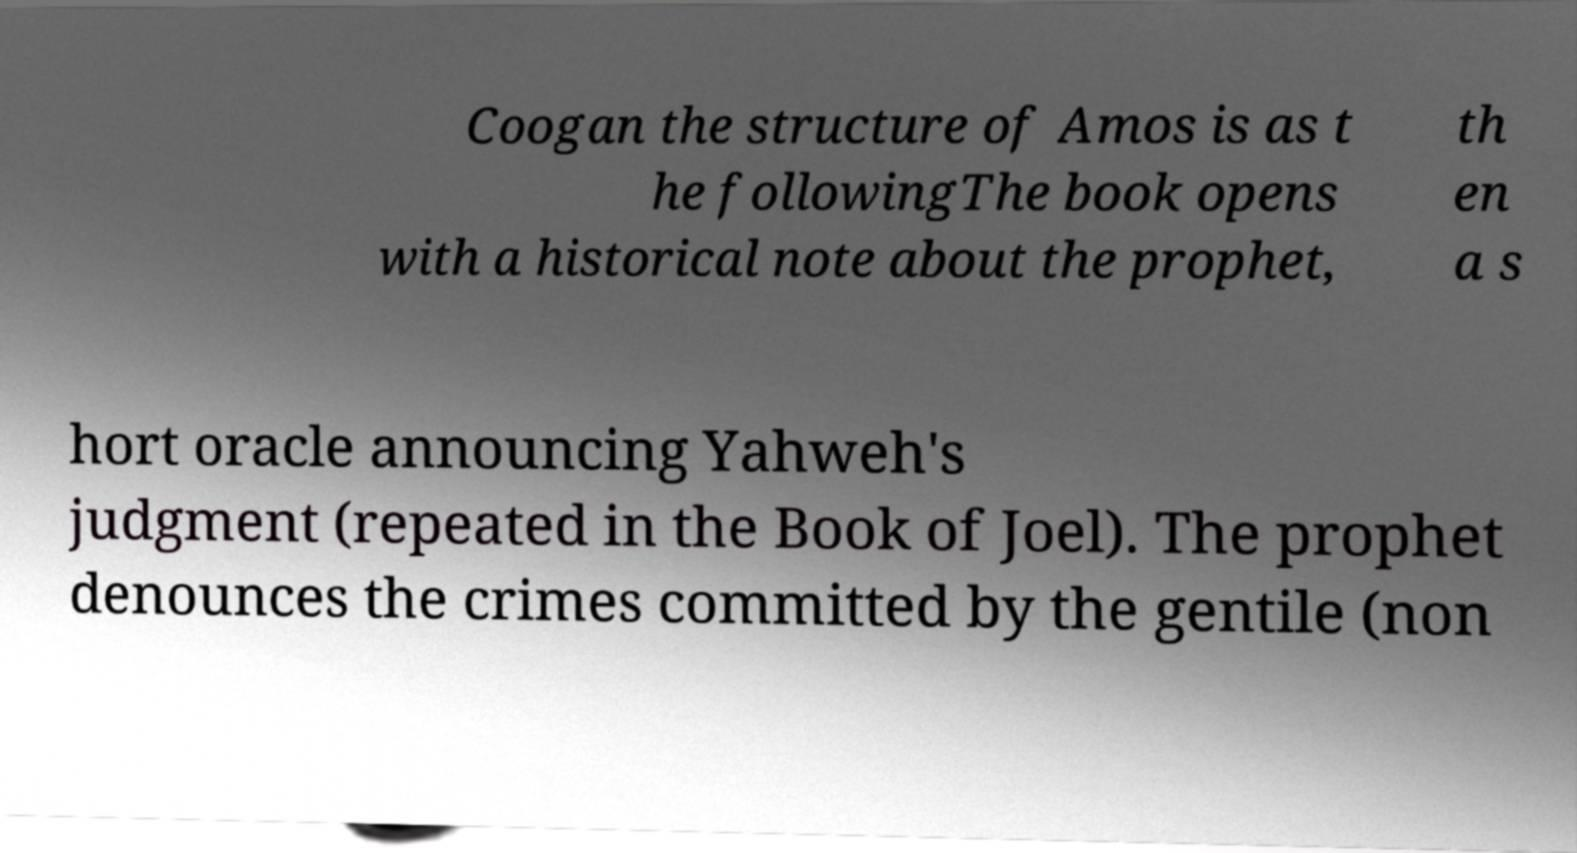I need the written content from this picture converted into text. Can you do that? Coogan the structure of Amos is as t he followingThe book opens with a historical note about the prophet, th en a s hort oracle announcing Yahweh's judgment (repeated in the Book of Joel). The prophet denounces the crimes committed by the gentile (non 